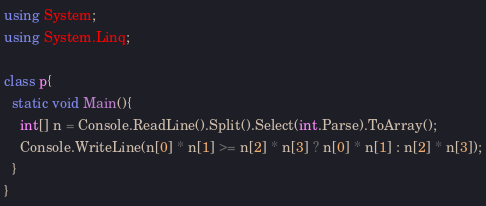Convert code to text. <code><loc_0><loc_0><loc_500><loc_500><_C#_>using System;
using System.Linq;

class p{
  static void Main(){
    int[] n = Console.ReadLine().Split().Select(int.Parse).ToArray();
    Console.WriteLine(n[0] * n[1] >= n[2] * n[3] ? n[0] * n[1] : n[2] * n[3]);
  }
}</code> 